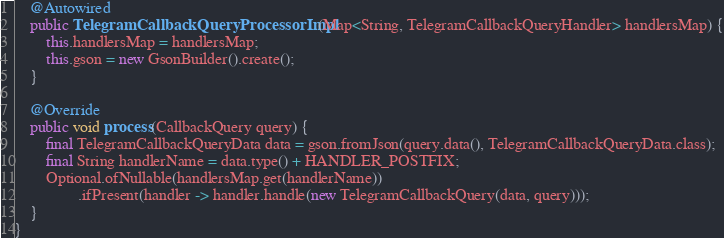Convert code to text. <code><loc_0><loc_0><loc_500><loc_500><_Java_>
    @Autowired
    public TelegramCallbackQueryProcessorImpl(Map<String, TelegramCallbackQueryHandler> handlersMap) {
        this.handlersMap = handlersMap;
        this.gson = new GsonBuilder().create();
    }

    @Override
    public void process(CallbackQuery query) {
        final TelegramCallbackQueryData data = gson.fromJson(query.data(), TelegramCallbackQueryData.class);
        final String handlerName = data.type() + HANDLER_POSTFIX;
        Optional.ofNullable(handlersMap.get(handlerName))
                .ifPresent(handler -> handler.handle(new TelegramCallbackQuery(data, query)));
    }
}
</code> 